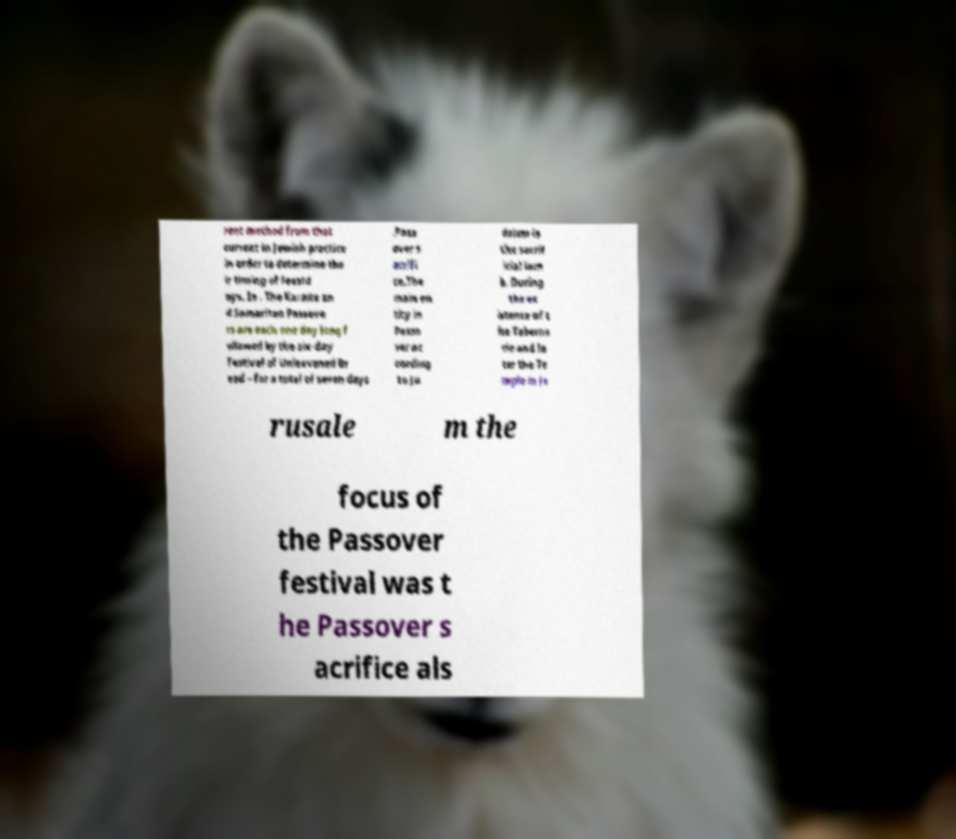What messages or text are displayed in this image? I need them in a readable, typed format. rent method from that current in Jewish practice in order to determine the ir timing of feastd ays. In . The Karaite an d Samaritan Passove rs are each one day long f ollowed by the six-day Festival of Unleavened Br ead – for a total of seven days .Pass over s acrifi ce.The main en tity in Passo ver ac cording to Ju daism is the sacrif icial lam b. During the ex istence of t he Taberna cle and la ter the Te mple in Je rusale m the focus of the Passover festival was t he Passover s acrifice als 